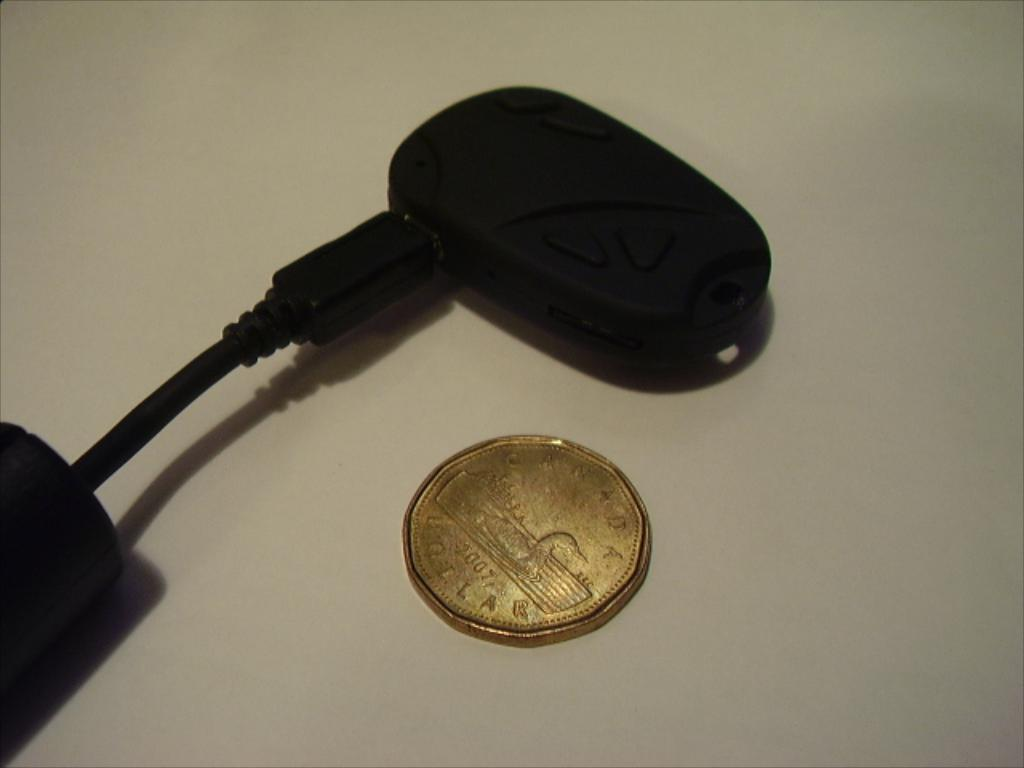What type of object can be seen in the image that has a gold color? There is a gold-colored coin in the image. What other object is present in the image that is not gold-colored? There is an electronic device in the image, and it is black in color. What feature of the electronic device is mentioned in the facts? The electronic device has a cable attached to it. What color is the background of the image? The background of the image is white in color. What grade does the cloud in the image receive for its performance? There is no cloud present in the image, so it is not possible to evaluate its performance or assign a grade. 